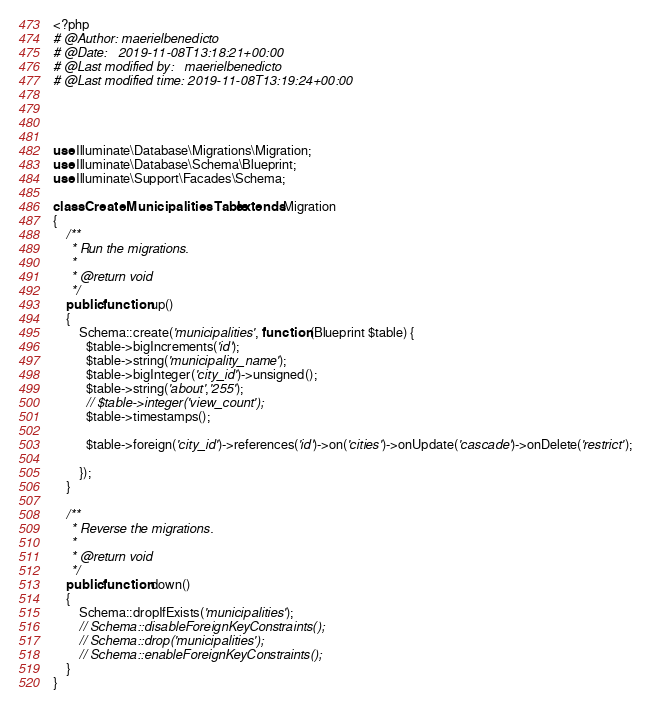Convert code to text. <code><loc_0><loc_0><loc_500><loc_500><_PHP_><?php
# @Author: maerielbenedicto
# @Date:   2019-11-08T13:18:21+00:00
# @Last modified by:   maerielbenedicto
# @Last modified time: 2019-11-08T13:19:24+00:00




use Illuminate\Database\Migrations\Migration;
use Illuminate\Database\Schema\Blueprint;
use Illuminate\Support\Facades\Schema;

class CreateMunicipalitiesTable extends Migration
{
    /**
     * Run the migrations.
     *
     * @return void
     */
    public function up()
    {
        Schema::create('municipalities', function (Blueprint $table) {
          $table->bigIncrements('id');
          $table->string('municipality_name');
          $table->bigInteger('city_id')->unsigned();
          $table->string('about','255');
          // $table->integer('view_count');
          $table->timestamps();

          $table->foreign('city_id')->references('id')->on('cities')->onUpdate('cascade')->onDelete('restrict');

        });
    }

    /**
     * Reverse the migrations.
     *
     * @return void
     */
    public function down()
    {
        Schema::dropIfExists('municipalities');
        // Schema::disableForeignKeyConstraints();
        // Schema::drop('municipalities');
        // Schema::enableForeignKeyConstraints();
    }
}
</code> 